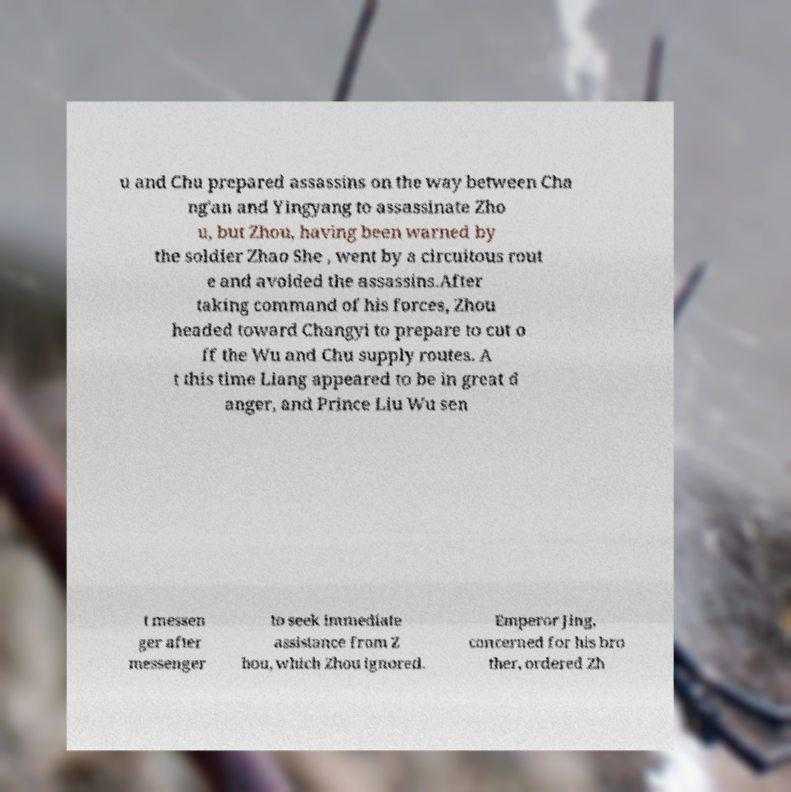Please read and relay the text visible in this image. What does it say? u and Chu prepared assassins on the way between Cha ng'an and Yingyang to assassinate Zho u, but Zhou, having been warned by the soldier Zhao She , went by a circuitous rout e and avoided the assassins.After taking command of his forces, Zhou headed toward Changyi to prepare to cut o ff the Wu and Chu supply routes. A t this time Liang appeared to be in great d anger, and Prince Liu Wu sen t messen ger after messenger to seek immediate assistance from Z hou, which Zhou ignored. Emperor Jing, concerned for his bro ther, ordered Zh 